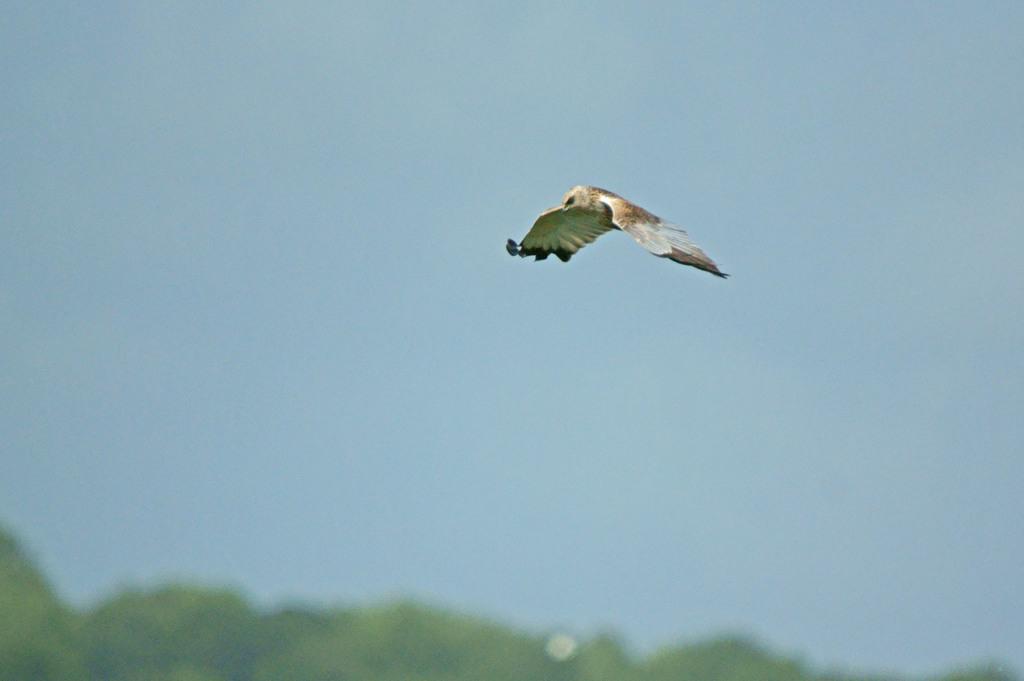In one or two sentences, can you explain what this image depicts? In this image, I can see a bird flying in the air. At the bottom of the image, there are trees. In the background, I can see the sky. 